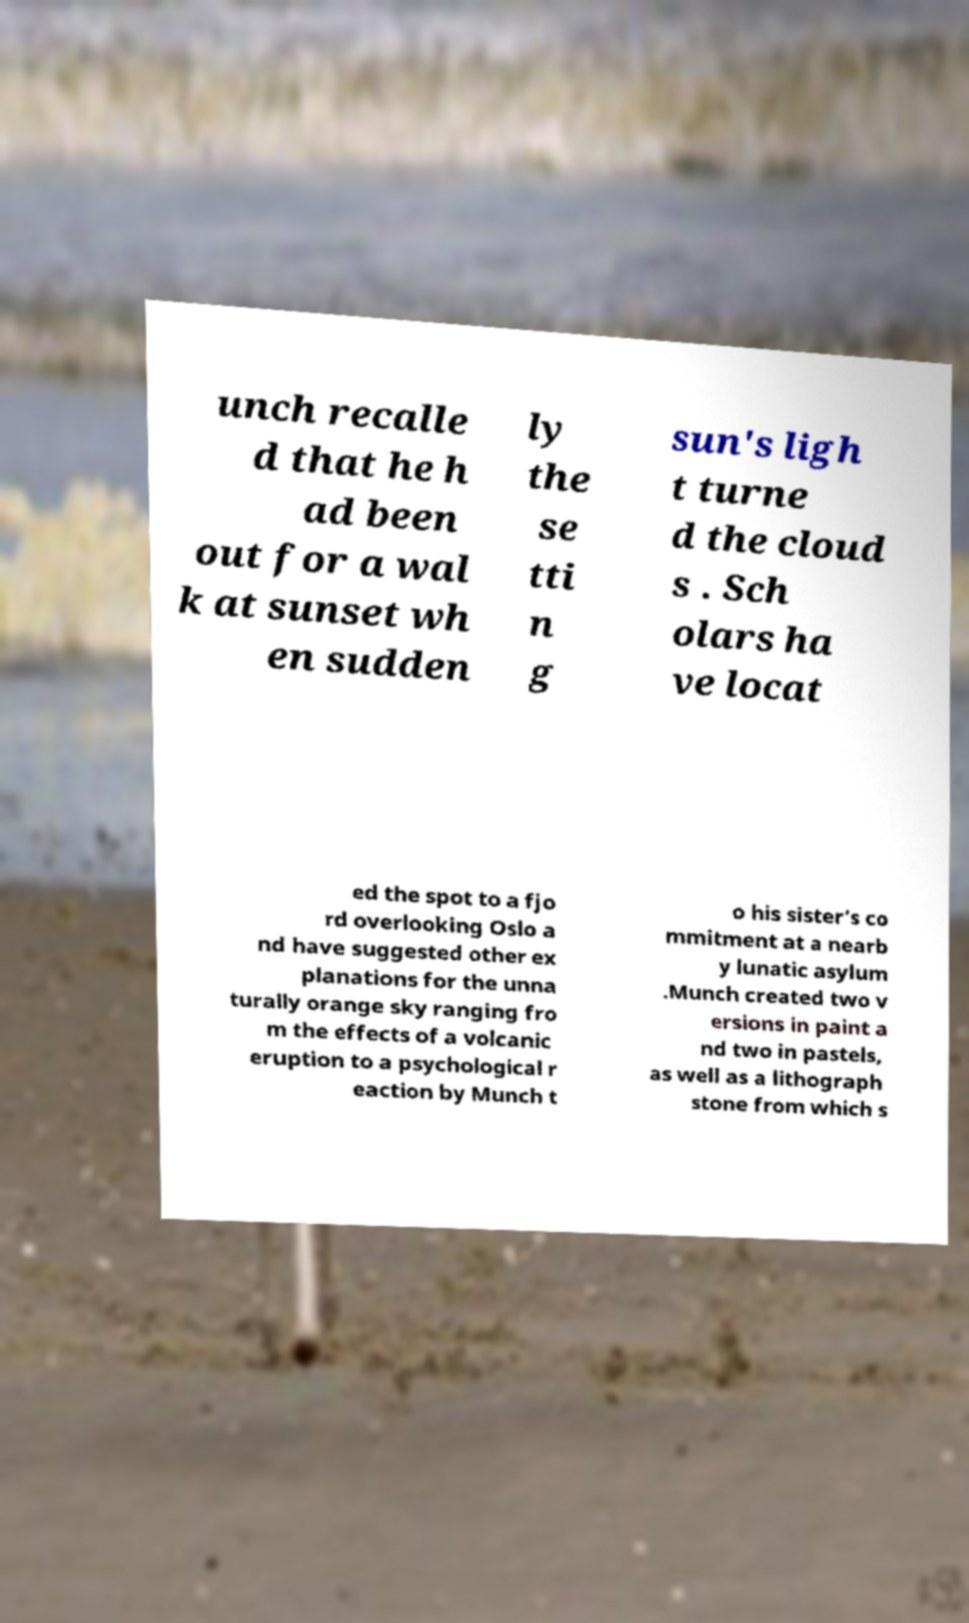Please read and relay the text visible in this image. What does it say? unch recalle d that he h ad been out for a wal k at sunset wh en sudden ly the se tti n g sun's ligh t turne d the cloud s . Sch olars ha ve locat ed the spot to a fjo rd overlooking Oslo a nd have suggested other ex planations for the unna turally orange sky ranging fro m the effects of a volcanic eruption to a psychological r eaction by Munch t o his sister’s co mmitment at a nearb y lunatic asylum .Munch created two v ersions in paint a nd two in pastels, as well as a lithograph stone from which s 